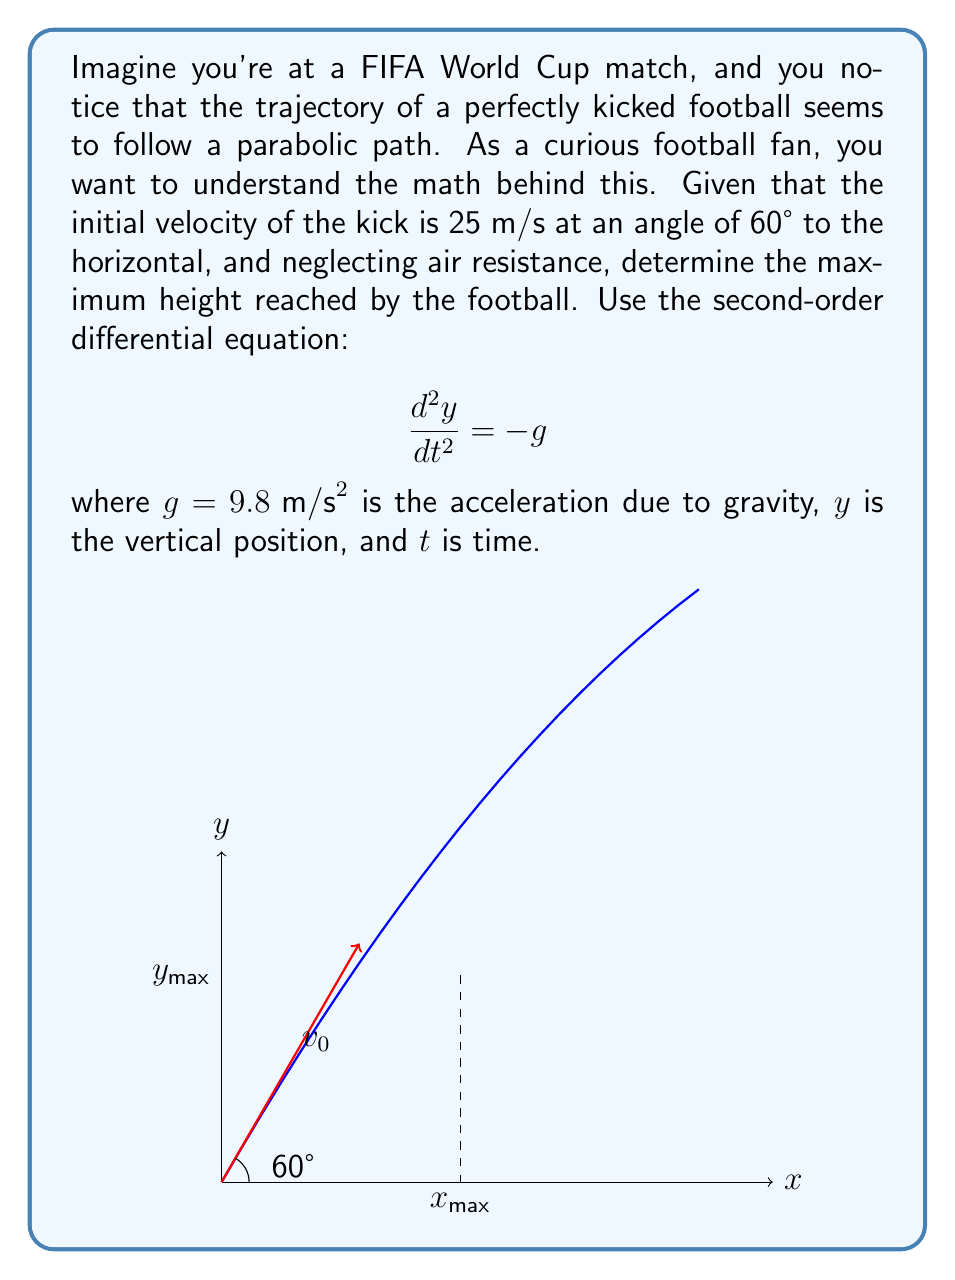What is the answer to this math problem? Let's approach this step-by-step:

1) The second-order differential equation $\frac{d^2y}{dt^2} = -g$ describes the vertical motion of the football.

2) Integrating once with respect to time:

   $\frac{dy}{dt} = -gt + C_1$

   where $C_1$ is a constant of integration.

3) The initial vertical velocity is $v_0\sin(60°)$. At $t=0$:

   $\frac{dy}{dt}(0) = v_0\sin(60°) = 25 \cdot \frac{\sqrt{3}}{2} = C_1$

4) So, $\frac{dy}{dt} = -gt + 25\frac{\sqrt{3}}{2}$

5) Integrating again:

   $y = -\frac{1}{2}gt^2 + 25\frac{\sqrt{3}}{2}t + C_2$

6) At $t=0$, $y=0$, so $C_2 = 0$.

7) The maximum height occurs when $\frac{dy}{dt} = 0$:

   $0 = -gt + 25\frac{\sqrt{3}}{2}$

   $t = \frac{25\sqrt{3}}{2g} = \frac{25\sqrt{3}}{2(9.8)} \approx 2.21$ seconds

8) Substituting this time back into the equation for $y$:

   $y_{max} = -\frac{1}{2}(9.8)(2.21)^2 + 25\frac{\sqrt{3}}{2}(2.21)$

   $y_{max} = -23.9 + 47.8 = 23.9$ meters

Therefore, the maximum height reached by the football is approximately 23.9 meters.
Answer: $23.9$ meters 